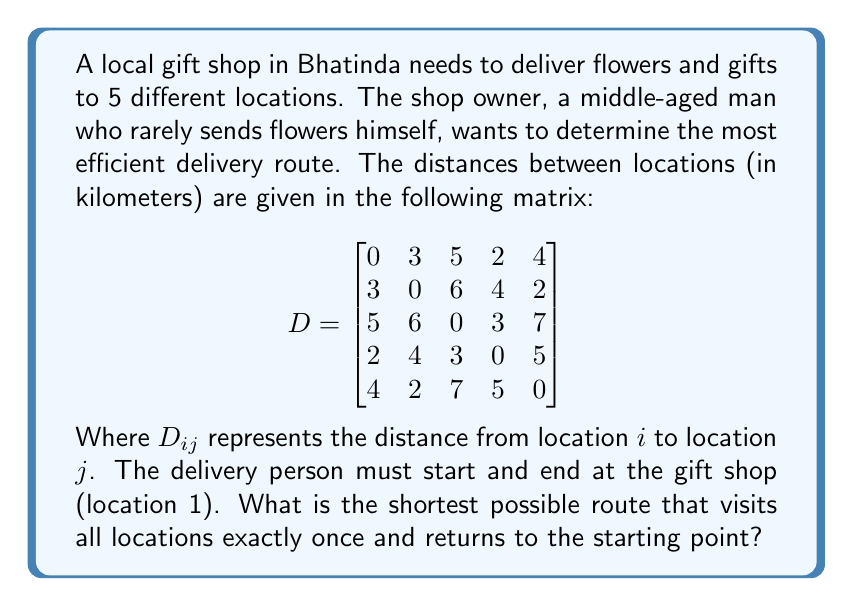Teach me how to tackle this problem. To solve this problem, we need to find the shortest Hamiltonian cycle in the given graph, which is known as the Traveling Salesman Problem (TSP). For a small number of locations like this, we can use a brute-force approach to check all possible permutations.

Steps:
1. List all possible permutations of locations 2, 3, 4, and 5.
2. For each permutation, calculate the total distance of the route including the start and end at location 1.
3. Compare all route distances to find the shortest one.

Possible permutations:
- 2-3-4-5
- 2-3-5-4
- 2-4-3-5
- 2-4-5-3
- 2-5-3-4
- 2-5-4-3
- 3-2-4-5
- 3-2-5-4
- 3-4-2-5
- 3-4-5-2
- 3-5-2-4
- 3-5-4-2
- 4-2-3-5
- 4-2-5-3
- 4-3-2-5
- 4-3-5-2
- 4-5-2-3
- 4-5-3-2
- 5-2-3-4
- 5-2-4-3
- 5-3-2-4
- 5-3-4-2
- 5-4-2-3
- 5-4-3-2

Calculating the distance for each permutation (showing only the shortest):

1-2-3-4-5-1: $3 + 6 + 3 + 5 + 4 = 21$ km

This route (1-2-3-4-5-1) gives the shortest total distance of 21 km.
Answer: The most efficient delivery route is 1-2-3-4-5-1, with a total distance of 21 km. 